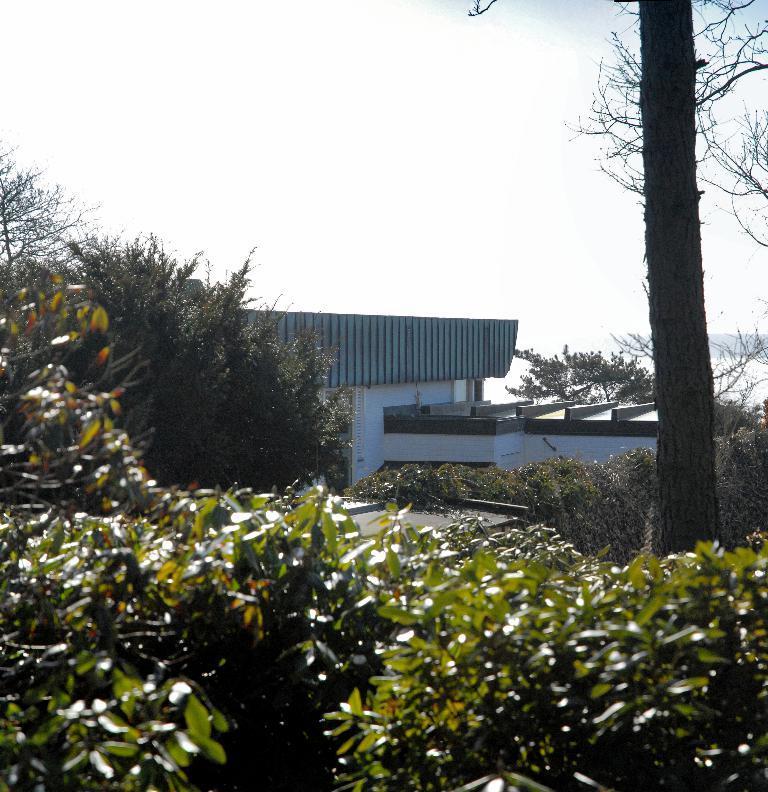Can you describe this image briefly? In this picture we can see there are trees and a building. At the top of the image, there is the sky. 